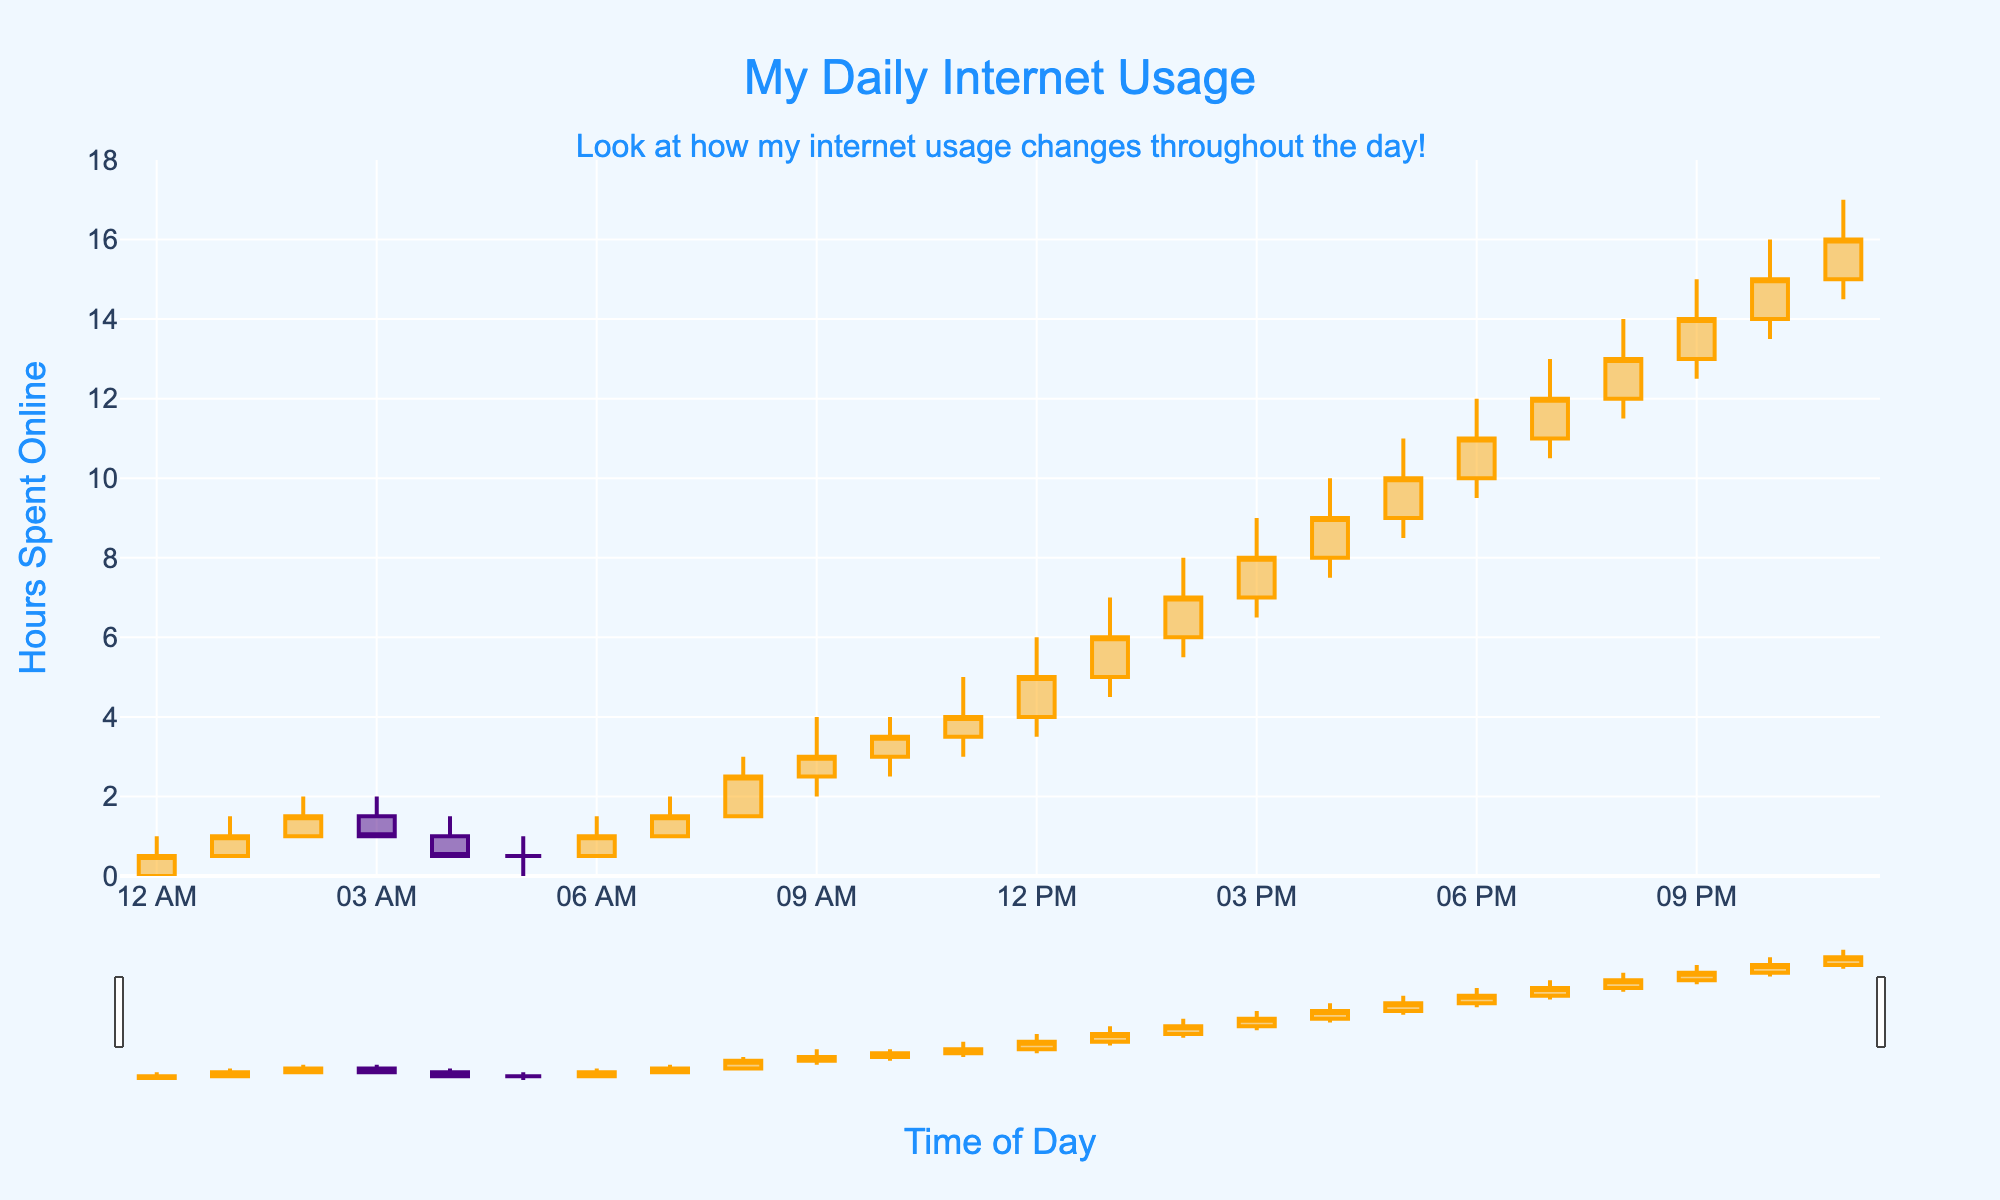What's the title of the plot? The title is centered at the top of the plot and reads "My Daily Internet Usage".
Answer: "My Daily Internet Usage" What are the colors indicating increasing and decreasing internet usage? The increasing usage is indicated by orange color, while the decreasing usage is indicated by indigo color.
Answer: Orange and Indigo What is the range of the y-axis? The y-axis ranges from 0 to 18 hours as indicated on the left side of the plot.
Answer: 0 to 18 hours At what hour did the internet usage reach its highest value? The highest value, indicated by the peak of the candle, occurs in the 2023-10-01 22:00 time slot, reaching 16 hours.
Answer: 22:00 How many hours of internet usage were recorded at 10:00? At 10:00, the closing value shows 3.5 hours of internet usage as per the plot.
Answer: 3.5 hours What time of the day did the usage start to increase dramatically and by how much? The usage started to increase dramatically at 08:00, rising from closing at 1.5 hours at 07:00 to a high of 3 hours at 08:00.
Answer: 08:00, 1.5 hours Compare the internet usage between 11:00 and 13:00. Which period saw a higher maximum usage? By inspecting the plot, 13:00 experienced a higher maximum usage of 7 hours compared to 11:00, which had a maximum usage of 5 hours.
Answer: 13:00 What is the trend of internet usage from 12:00 to 15:00? From 12:00 to 15:00, the internet usage steadily increases from 5 hours to 8 hours, as observed from the closing values on the plot.
Answer: Increasing trend Calculate the average closing usage between 17:00 and 20:00. The closing values between 17:00 and 20:00 are 10, 11, 12, and 13. The sum is 46, and there are 4 values, so the average is 46/4 = 11.5 hours.
Answer: 11.5 hours Which hour had the highest difference between the high and low values? The hour 2023-10-01 12:00 had a high of 6 and a low of 3.5, resulting in a difference of 2.5 hours, the highest difference in the plot.
Answer: 12:00 